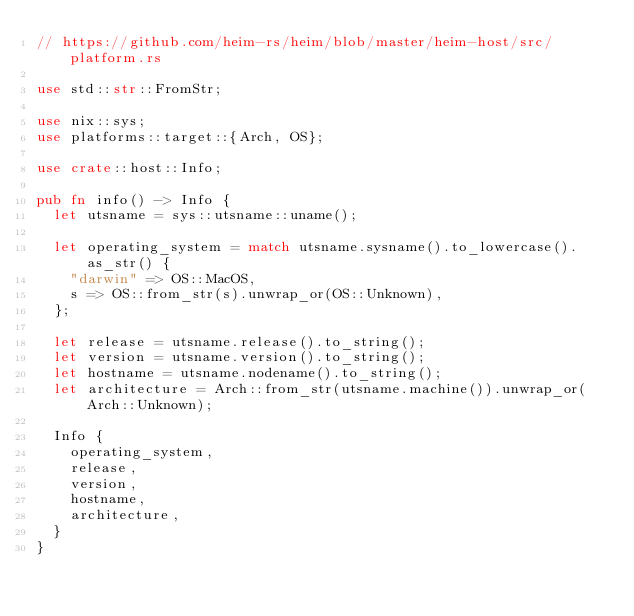<code> <loc_0><loc_0><loc_500><loc_500><_Rust_>// https://github.com/heim-rs/heim/blob/master/heim-host/src/platform.rs

use std::str::FromStr;

use nix::sys;
use platforms::target::{Arch, OS};

use crate::host::Info;

pub fn info() -> Info {
	let utsname = sys::utsname::uname();

	let operating_system = match utsname.sysname().to_lowercase().as_str() {
		"darwin" => OS::MacOS,
		s => OS::from_str(s).unwrap_or(OS::Unknown),
	};

	let release = utsname.release().to_string();
	let version = utsname.version().to_string();
	let hostname = utsname.nodename().to_string();
	let architecture = Arch::from_str(utsname.machine()).unwrap_or(Arch::Unknown);

	Info {
		operating_system,
		release,
		version,
		hostname,
		architecture,
	}
}
</code> 